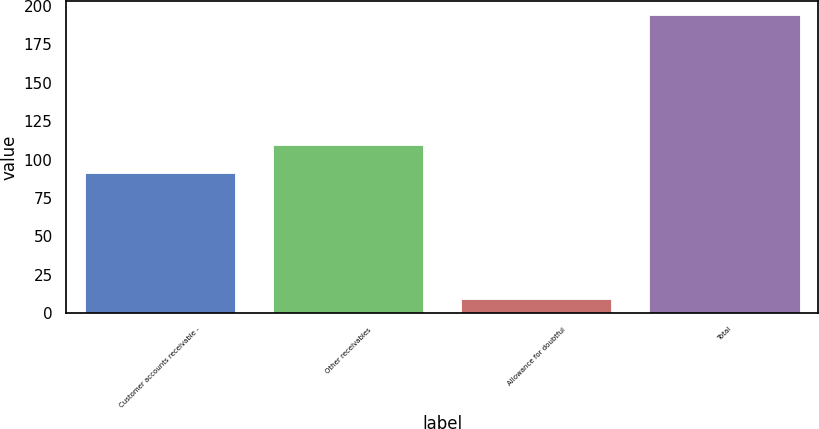<chart> <loc_0><loc_0><loc_500><loc_500><bar_chart><fcel>Customer accounts receivable -<fcel>Other receivables<fcel>Allowance for doubtful<fcel>Total<nl><fcel>91.2<fcel>109.65<fcel>9.2<fcel>193.7<nl></chart> 